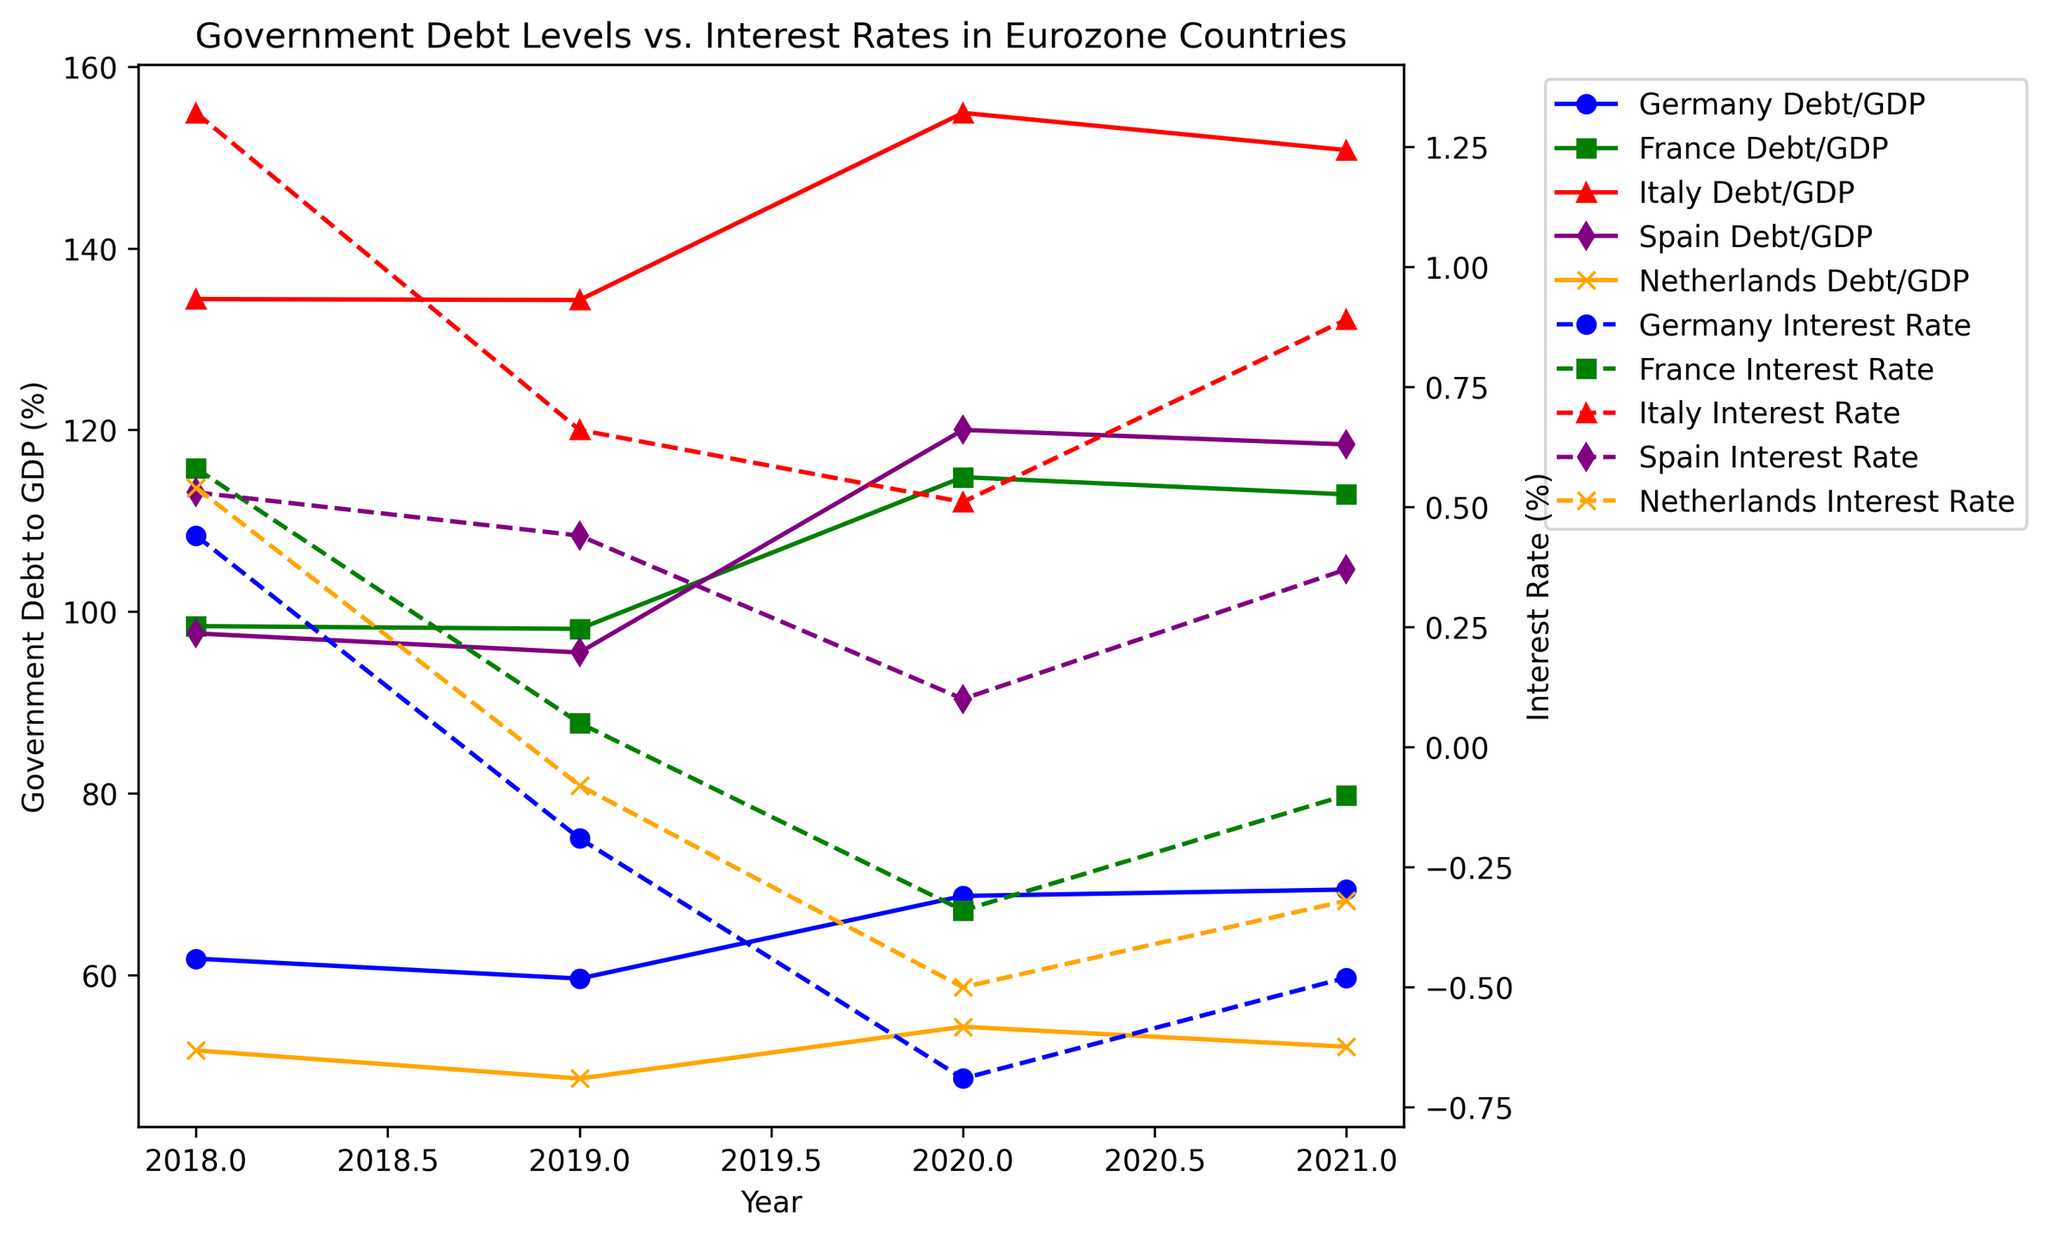What trend can you observe in Germany's government debt to GDP ratio from 2018 to 2021? From the figure, you can see that Germany's government debt to GDP ratio first decreases from 61.8% in 2018 to 59.6% in 2019. It then increases to 68.7% in 2020 and slightly rises to 69.4% in 2021. The trend indicates a decrease followed by an increase.
Answer: Decrease then Increase How does Italy's government debt to GDP ratio in 2020 compare to France's in the same year? The figure shows Italy's government debt to GDP ratio in 2020 is 154.9%, whereas France's is 114.8%. By comparing the two values, Italy's ratio is higher than France's.
Answer: Italy's is higher Which country had the lowest interest rate in 2019? Looking at the interest rates for each country in 2019, Germany's interest rate is the lowest at -0.19%, compared to France's 0.05%, Italy’s 0.66%, Spain’s 0.44%, and the Netherlands' -0.08%.
Answer: Germany Compare the government debt to GDP ratio of Spain between 2018 and 2021. What is the overall change? The graph shows Spain’s government debt to GDP ratio in 2018 was 97.6%, and it was 118.4% in 2021. The overall change is calculated by subtracting the 2018 value from the 2021 value: 118.4% - 97.6% = 20.8%.
Answer: Increase by 20.8% How did France's interest rate change from 2018 to 2021? From the figure, France’s interest rate was 0.58% in 2018 and changed to -0.10% in 2021. The change can be calculated by subtracting the 2021 value from the 2018 value: 0.58% - (-0.10%) = 0.68%. This shows a decrease.
Answer: Decrease by 0.68% What is the relationship between the government debt to GDP ratio and interest rate for the Netherlands from 2019 to 2021? Observing the figure, the Netherlands' government debt to GDP ratio increased from 48.6% in 2019 to 54.3% in 2020 and slightly decreased to 52.1% in 2021. The interest rate during this period is -0.08% in 2019, which becomes more negative; -0.50% in 2020 and -0.32% in 2021. The relationship shows that as the debt ratio increases, the interest rate becomes more negative.
Answer: Debt ratio up, Interest rate down 